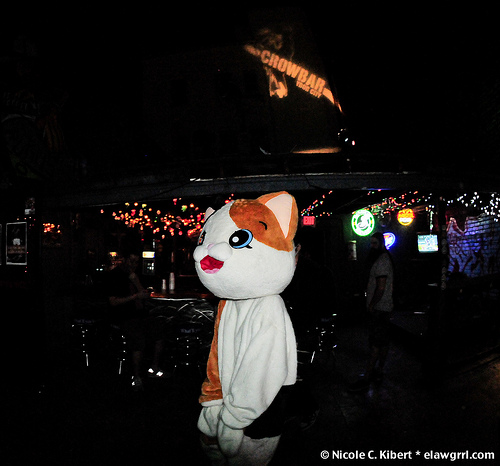<image>
Is there a cat in the bar? Yes. The cat is contained within or inside the bar, showing a containment relationship. 